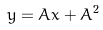Convert formula to latex. <formula><loc_0><loc_0><loc_500><loc_500>y = A x + A ^ { 2 }</formula> 